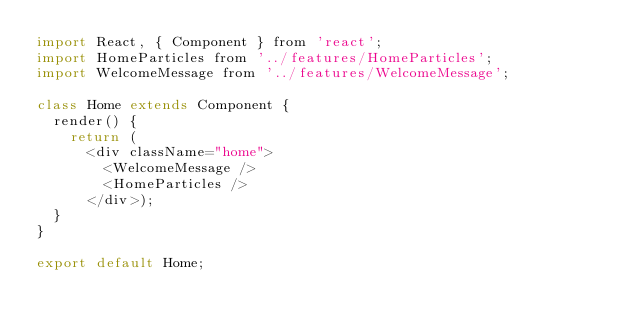Convert code to text. <code><loc_0><loc_0><loc_500><loc_500><_JavaScript_>import React, { Component } from 'react';
import HomeParticles from '../features/HomeParticles';
import WelcomeMessage from '../features/WelcomeMessage';

class Home extends Component {
  render() {
    return (
      <div className="home">
        <WelcomeMessage />
        <HomeParticles />
      </div>);
  }
}

export default Home;</code> 